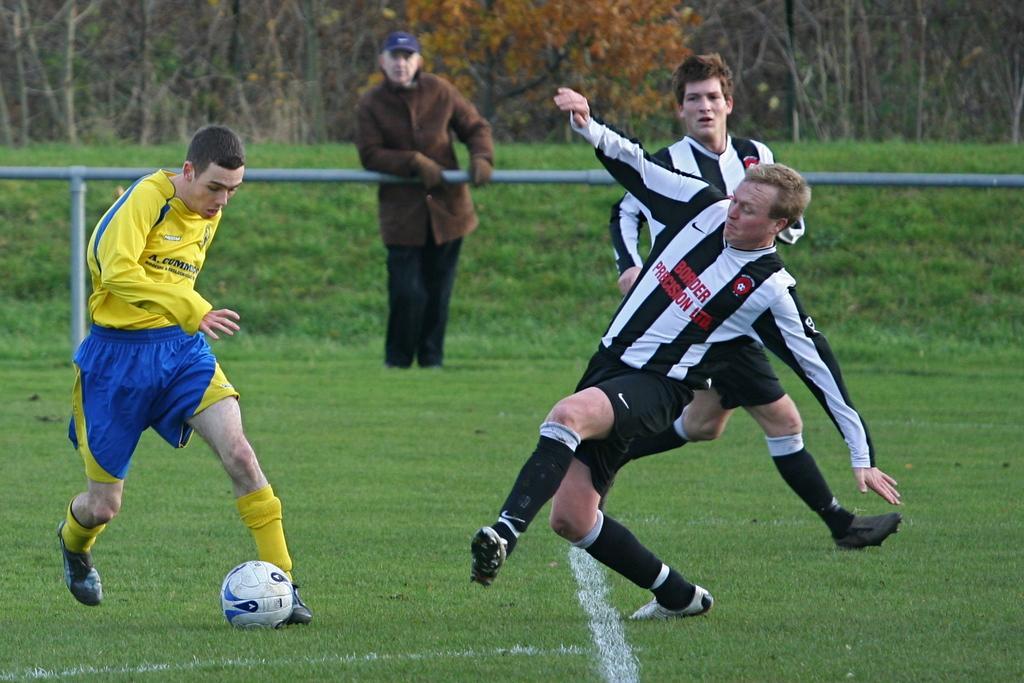Could you give a brief overview of what you see in this image? Here in the image we can see three people were playing football. In the ground(green ground) and in the center one man is standing and looking at the people. And coming to the background they were some trees. 